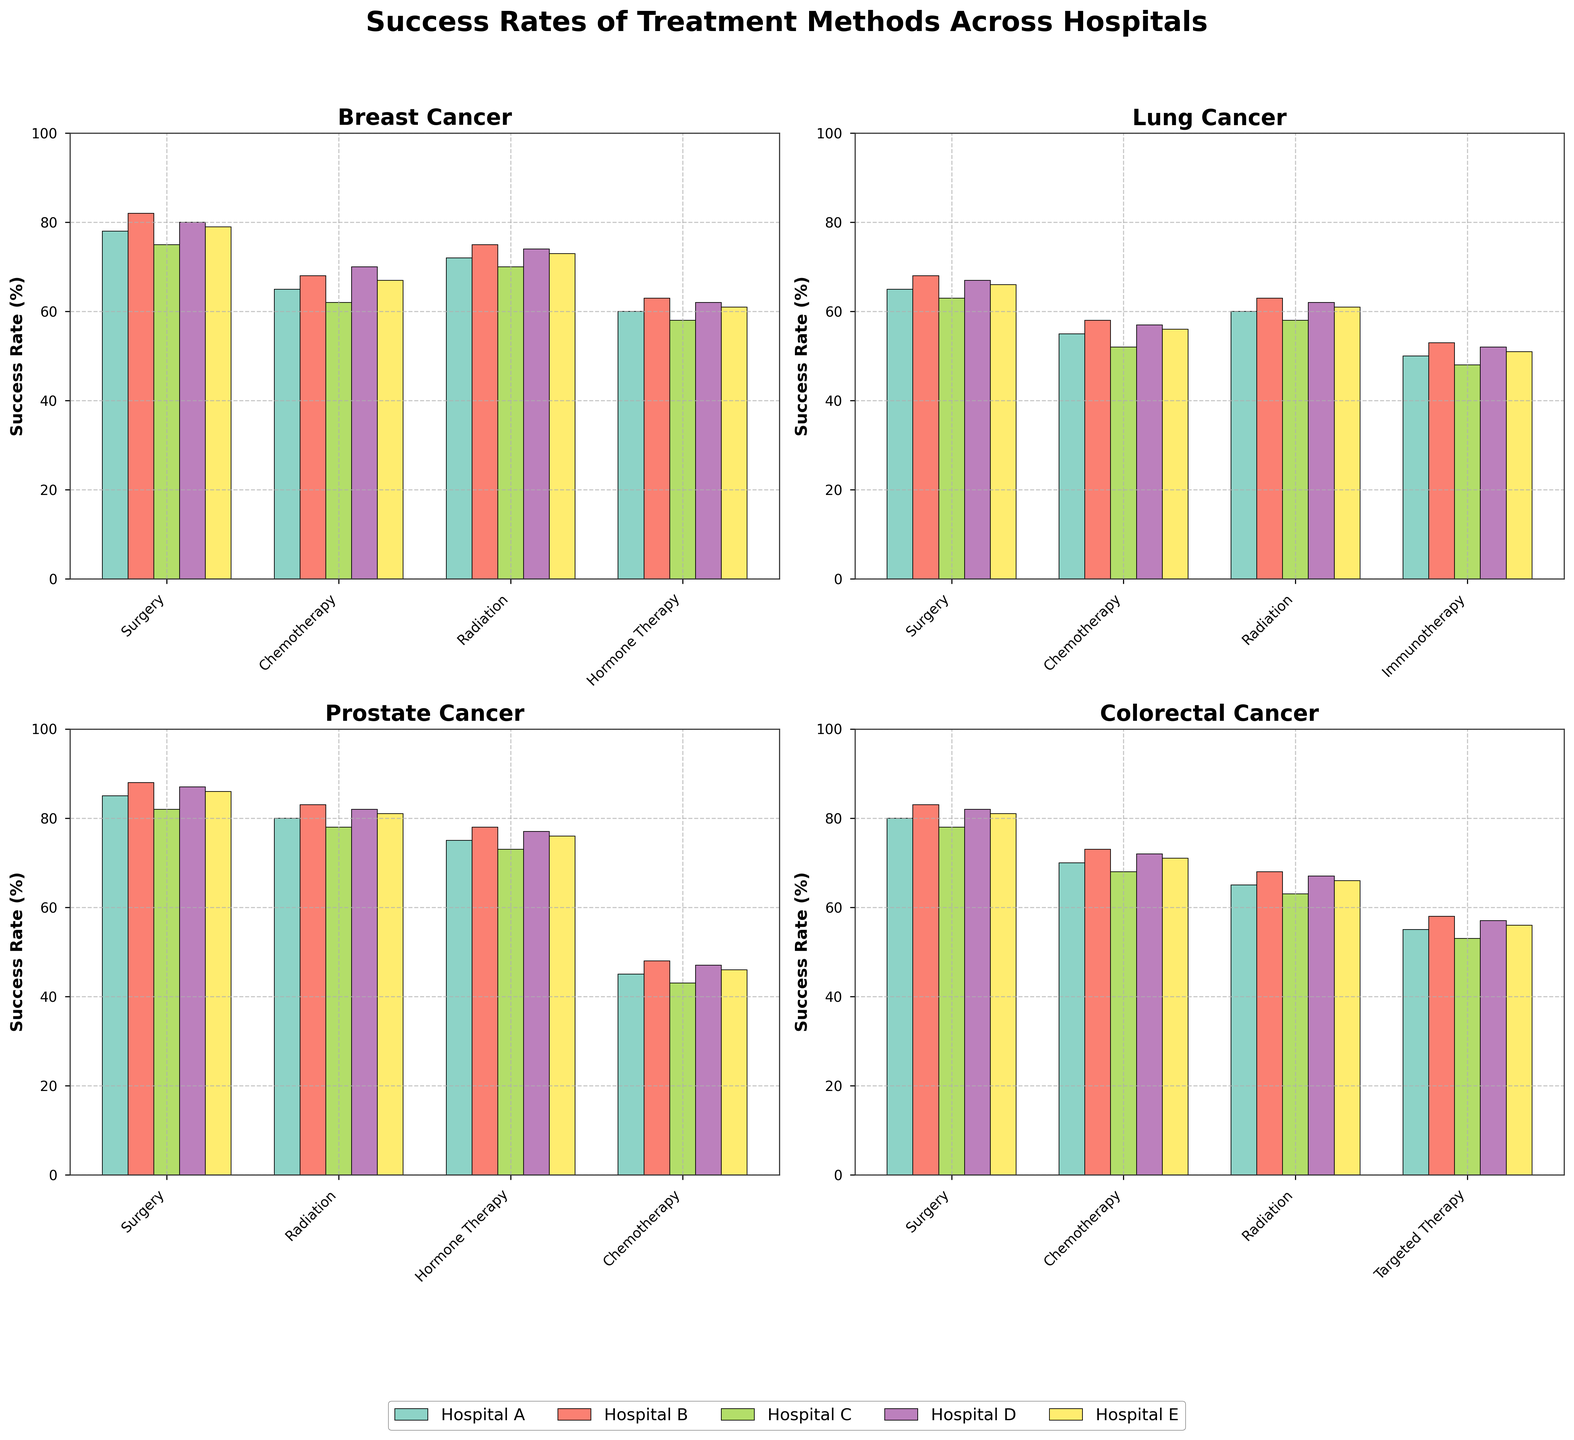Which hospital has the highest success rate for Breast Cancer surgery? Look at the bar heights for Breast Cancer Surgery across all hospitals. Hospital B has the tallest bar at 82%.
Answer: Hospital B Compare the success rate of Chemotherapy for Lung Cancer and Breast Cancer across all hospitals. For Lung Cancer, the success rates are: Hospital A (55%), Hospital B (58%), Hospital C (52%), Hospital D (57%), and Hospital E (56%). For Breast Cancer, the rates are: Hospital A (65%), Hospital B (68%), Hospital C (62%), Hospital D (70%), and Hospital E (67%). Breast Cancer consistently shows higher rates.
Answer: Breast Cancer rates are higher What is the average success rate for Radiation treatment for Breast Cancer across all hospitals? The values are 72%, 75%, 70%, 74%, and 73%. Summing these up gives 364, and the average is 364/5 = 72.8%.
Answer: 72.8% Which treatment method has the lowest success rate for Prostate Cancer? Look at the bars for Prostate Cancer and identify the shortest one. It is Chemotherapy, with the lowest values across all hospitals.
Answer: Chemotherapy What is the difference in success rates of Surgery for Lung Cancer between Hospital A and Hospital B? The success rate for Hospital A is 65%, and for Hospital B is 68%. The difference is 68 - 65 = 3%.
Answer: 3% How does the success rate of Hormone Therapy compare between Breast Cancer and Prostate Cancer in Hospital A? For Breast Cancer, the success rate is 60%. For Prostate Cancer, it's 75%. Prostate Cancer has a higher success rate by 15%.
Answer: Prostate Cancer is higher by 15% What is the combined success rate of all treatments for Colorectal Cancer in Hospital C? The success rates are: Surgery (78%), Chemotherapy (68%), Radiation (63%), Targeted Therapy (53%). Combined, they sum to 262%.
Answer: 262% Which hospital shows the most consistent success rates across all treatments for Lung Cancer? By visually scanning the heights of the bars for Lung Cancer, Hospital E seems to have the least variation across treatments.
Answer: Hospital E Identify the highest and lowest success rates for Surgery in different hospitals across all diseases. Identify the tallest and shortest bars in the Surgery category. The highest rate is for Prostate Cancer in Hospital B at 88%, and the lowest is for Lung Cancer in Hospital C at 63%.
Answer: Highest: Hospital B, 88% (Prostate Cancer); Lowest: Hospital C, 63% (Lung Cancer) What is the average success rate of Hormone Therapy for Breast Cancer across Hospital C and Hospital E? Breast Cancer success rates for Hormone Therapy are 58% (Hospital C) and 61% (Hospital E). The average is (58 + 61)/2 = 59.5%.
Answer: 59.5% 